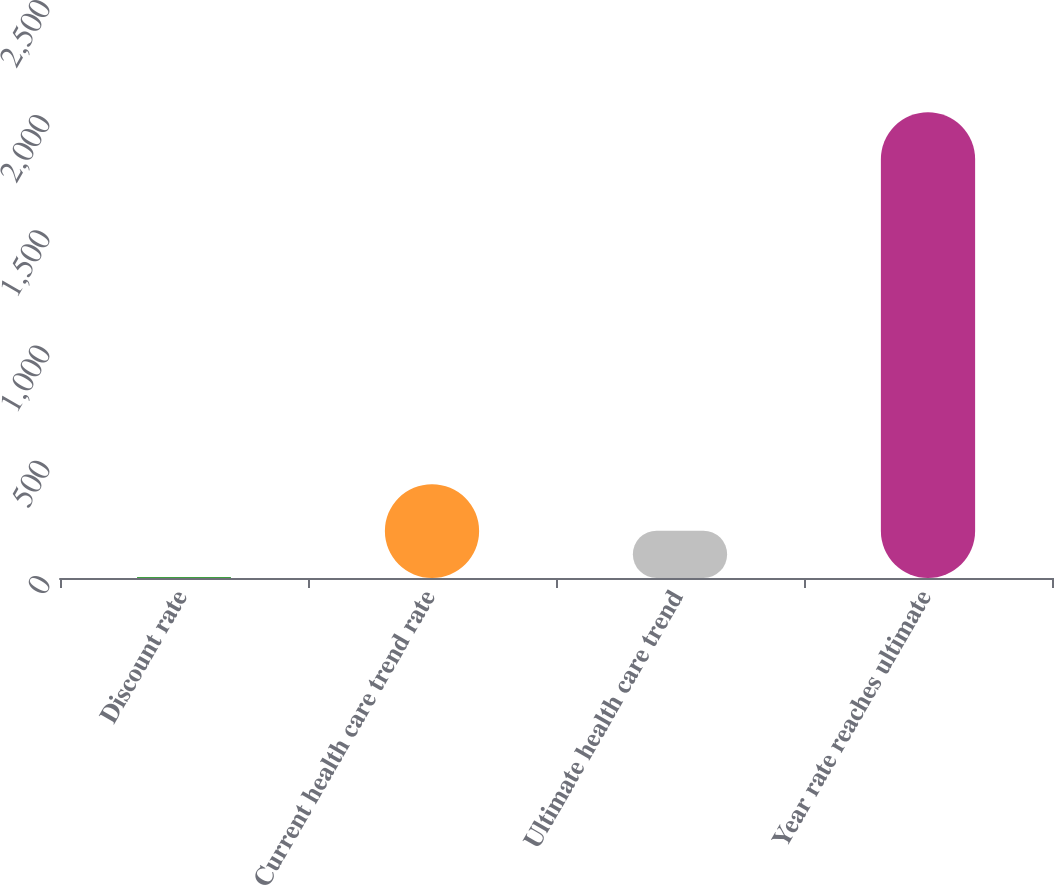Convert chart. <chart><loc_0><loc_0><loc_500><loc_500><bar_chart><fcel>Discount rate<fcel>Current health care trend rate<fcel>Ultimate health care trend<fcel>Year rate reaches ultimate<nl><fcel>3.7<fcel>407.36<fcel>205.53<fcel>2022<nl></chart> 